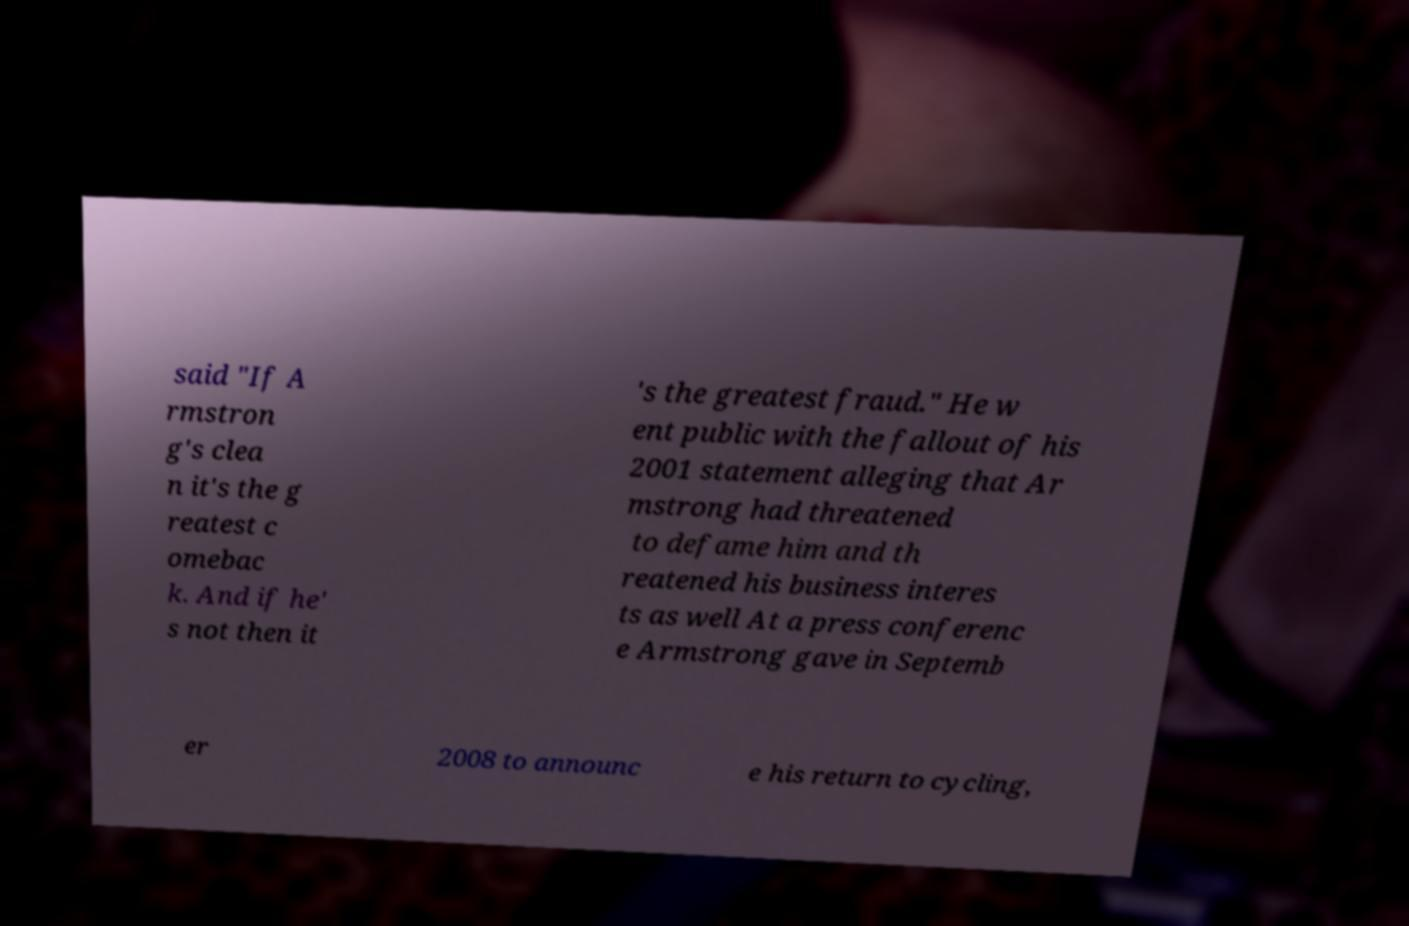Please identify and transcribe the text found in this image. said "If A rmstron g's clea n it's the g reatest c omebac k. And if he' s not then it 's the greatest fraud." He w ent public with the fallout of his 2001 statement alleging that Ar mstrong had threatened to defame him and th reatened his business interes ts as well At a press conferenc e Armstrong gave in Septemb er 2008 to announc e his return to cycling, 